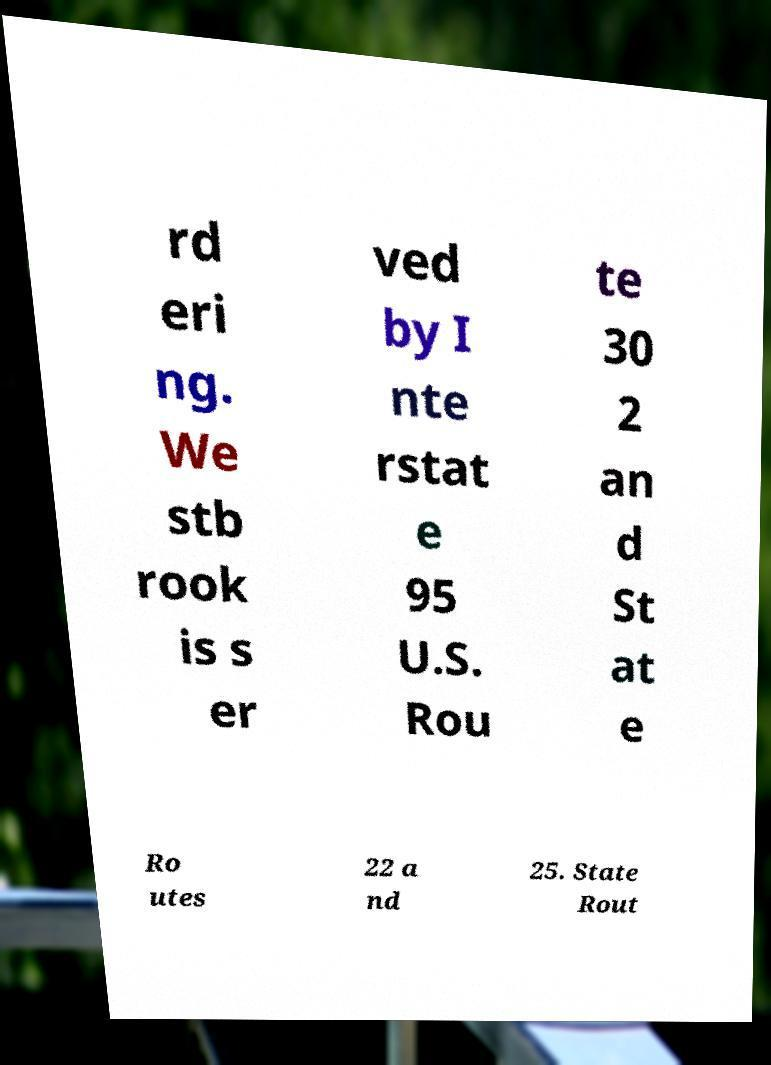What messages or text are displayed in this image? I need them in a readable, typed format. rd eri ng. We stb rook is s er ved by I nte rstat e 95 U.S. Rou te 30 2 an d St at e Ro utes 22 a nd 25. State Rout 